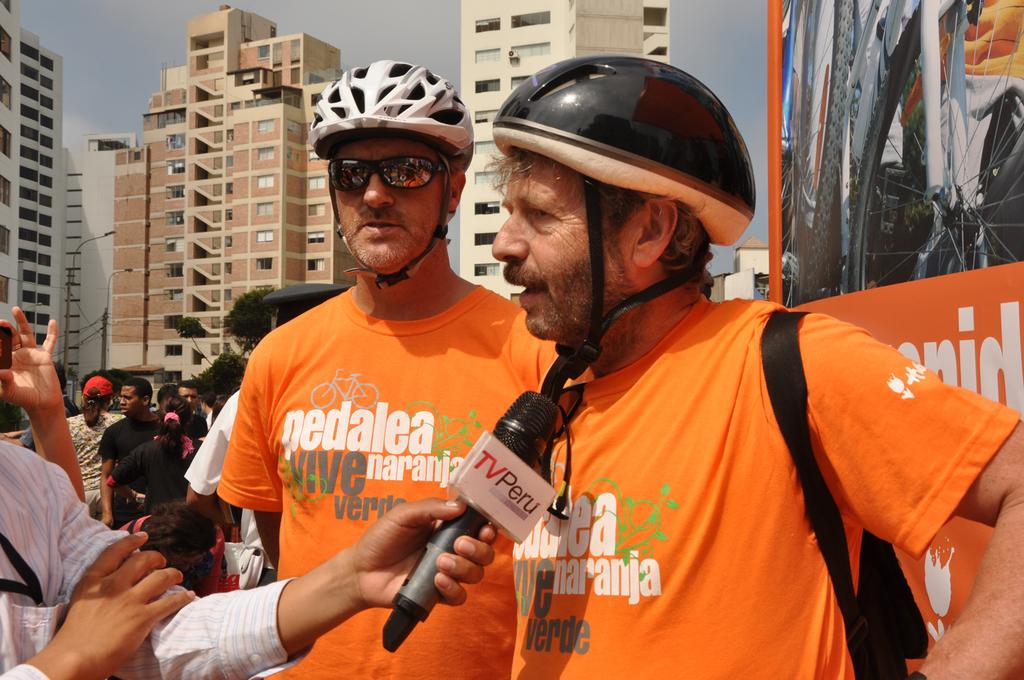Who or what can be seen in the image? There are people in the image. What else is present in the image besides people? There are banners, a mic, helmets, and buildings in the image. What might be used for amplifying sound in the image? There is a mic in the image for amplifying sound. What is visible at the top of the image? The sky is visible at the top of the image. What type of quilt is being used to cover the minister in the image? There is no minister or quilt present in the image. How does the air affect the people in the image? The provided facts do not mention any information about the air or its effects on the people in the image. 